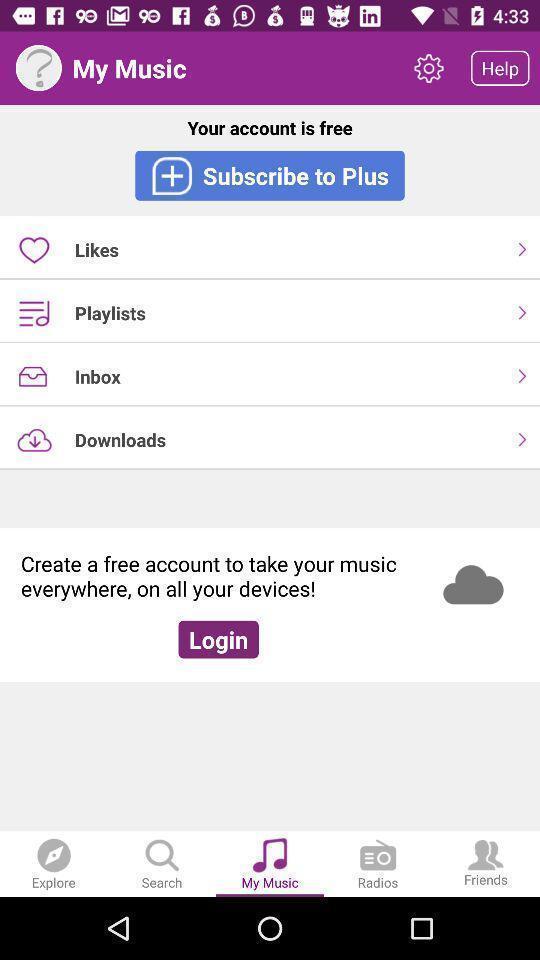Explain what's happening in this screen capture. Page showing various options on music app. 